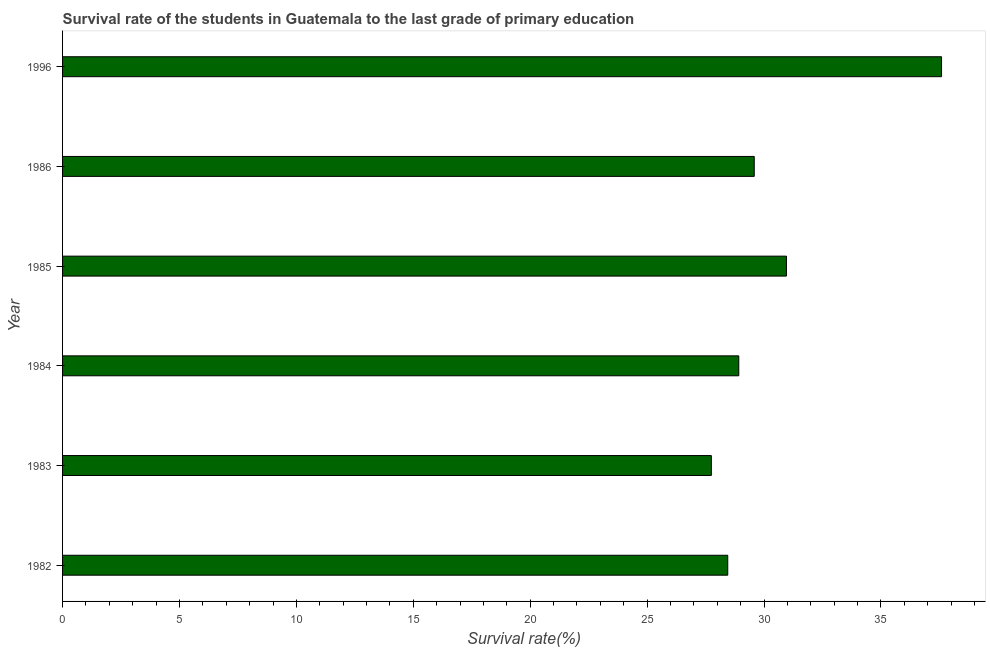Does the graph contain any zero values?
Your answer should be compact. No. What is the title of the graph?
Make the answer very short. Survival rate of the students in Guatemala to the last grade of primary education. What is the label or title of the X-axis?
Give a very brief answer. Survival rate(%). What is the survival rate in primary education in 1984?
Keep it short and to the point. 28.92. Across all years, what is the maximum survival rate in primary education?
Your response must be concise. 37.59. Across all years, what is the minimum survival rate in primary education?
Your answer should be compact. 27.75. In which year was the survival rate in primary education minimum?
Give a very brief answer. 1983. What is the sum of the survival rate in primary education?
Offer a terse response. 183.26. What is the difference between the survival rate in primary education in 1982 and 1996?
Make the answer very short. -9.14. What is the average survival rate in primary education per year?
Your answer should be compact. 30.54. What is the median survival rate in primary education?
Your answer should be very brief. 29.25. In how many years, is the survival rate in primary education greater than 33 %?
Give a very brief answer. 1. Do a majority of the years between 1986 and 1996 (inclusive) have survival rate in primary education greater than 23 %?
Your answer should be compact. Yes. What is the ratio of the survival rate in primary education in 1983 to that in 1986?
Make the answer very short. 0.94. What is the difference between the highest and the second highest survival rate in primary education?
Provide a short and direct response. 6.63. What is the difference between the highest and the lowest survival rate in primary education?
Your answer should be very brief. 9.85. How many bars are there?
Make the answer very short. 6. Are all the bars in the graph horizontal?
Give a very brief answer. Yes. What is the Survival rate(%) of 1982?
Give a very brief answer. 28.45. What is the Survival rate(%) in 1983?
Offer a very short reply. 27.75. What is the Survival rate(%) in 1984?
Your answer should be compact. 28.92. What is the Survival rate(%) in 1985?
Your response must be concise. 30.96. What is the Survival rate(%) of 1986?
Your answer should be compact. 29.58. What is the Survival rate(%) in 1996?
Give a very brief answer. 37.59. What is the difference between the Survival rate(%) in 1982 and 1983?
Keep it short and to the point. 0.7. What is the difference between the Survival rate(%) in 1982 and 1984?
Your answer should be very brief. -0.47. What is the difference between the Survival rate(%) in 1982 and 1985?
Make the answer very short. -2.51. What is the difference between the Survival rate(%) in 1982 and 1986?
Make the answer very short. -1.13. What is the difference between the Survival rate(%) in 1982 and 1996?
Your answer should be very brief. -9.14. What is the difference between the Survival rate(%) in 1983 and 1984?
Your answer should be very brief. -1.17. What is the difference between the Survival rate(%) in 1983 and 1985?
Keep it short and to the point. -3.21. What is the difference between the Survival rate(%) in 1983 and 1986?
Ensure brevity in your answer.  -1.84. What is the difference between the Survival rate(%) in 1983 and 1996?
Your response must be concise. -9.85. What is the difference between the Survival rate(%) in 1984 and 1985?
Provide a short and direct response. -2.04. What is the difference between the Survival rate(%) in 1984 and 1986?
Offer a very short reply. -0.66. What is the difference between the Survival rate(%) in 1984 and 1996?
Keep it short and to the point. -8.67. What is the difference between the Survival rate(%) in 1985 and 1986?
Give a very brief answer. 1.38. What is the difference between the Survival rate(%) in 1985 and 1996?
Provide a short and direct response. -6.63. What is the difference between the Survival rate(%) in 1986 and 1996?
Ensure brevity in your answer.  -8.01. What is the ratio of the Survival rate(%) in 1982 to that in 1983?
Give a very brief answer. 1.02. What is the ratio of the Survival rate(%) in 1982 to that in 1984?
Offer a terse response. 0.98. What is the ratio of the Survival rate(%) in 1982 to that in 1985?
Offer a terse response. 0.92. What is the ratio of the Survival rate(%) in 1982 to that in 1996?
Your answer should be compact. 0.76. What is the ratio of the Survival rate(%) in 1983 to that in 1984?
Offer a very short reply. 0.96. What is the ratio of the Survival rate(%) in 1983 to that in 1985?
Offer a terse response. 0.9. What is the ratio of the Survival rate(%) in 1983 to that in 1986?
Offer a terse response. 0.94. What is the ratio of the Survival rate(%) in 1983 to that in 1996?
Offer a very short reply. 0.74. What is the ratio of the Survival rate(%) in 1984 to that in 1985?
Make the answer very short. 0.93. What is the ratio of the Survival rate(%) in 1984 to that in 1996?
Give a very brief answer. 0.77. What is the ratio of the Survival rate(%) in 1985 to that in 1986?
Keep it short and to the point. 1.05. What is the ratio of the Survival rate(%) in 1985 to that in 1996?
Ensure brevity in your answer.  0.82. What is the ratio of the Survival rate(%) in 1986 to that in 1996?
Offer a very short reply. 0.79. 